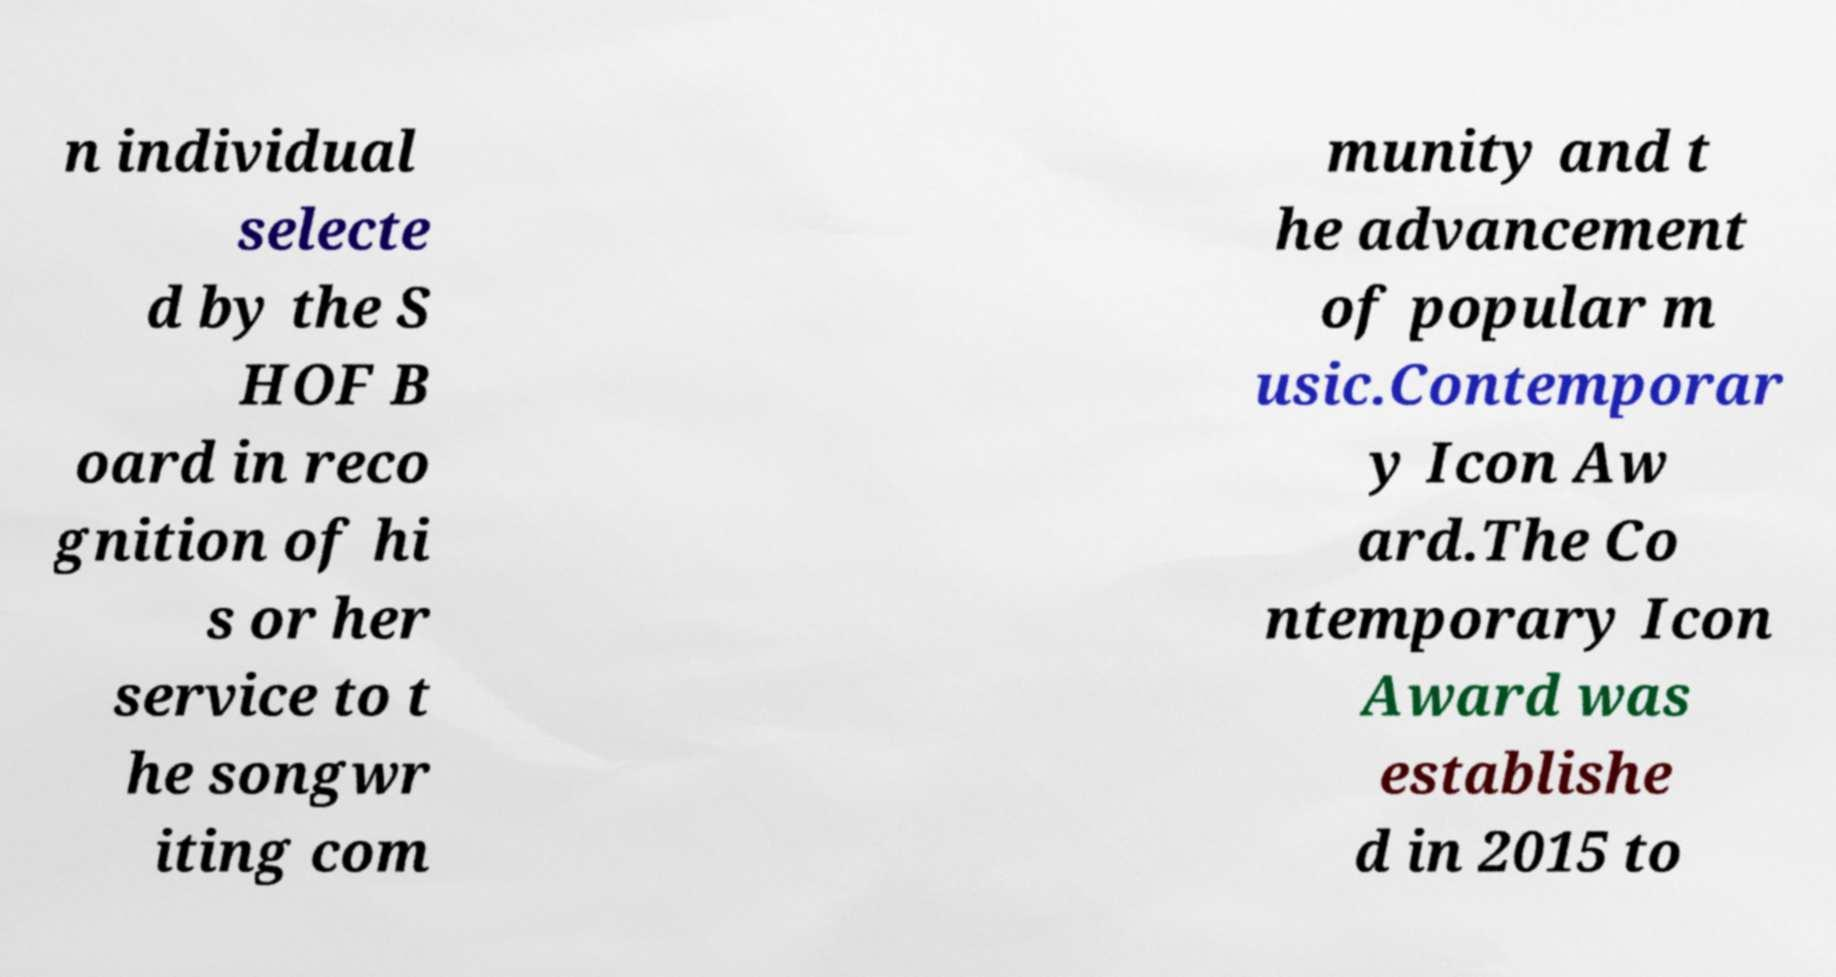Please read and relay the text visible in this image. What does it say? n individual selecte d by the S HOF B oard in reco gnition of hi s or her service to t he songwr iting com munity and t he advancement of popular m usic.Contemporar y Icon Aw ard.The Co ntemporary Icon Award was establishe d in 2015 to 